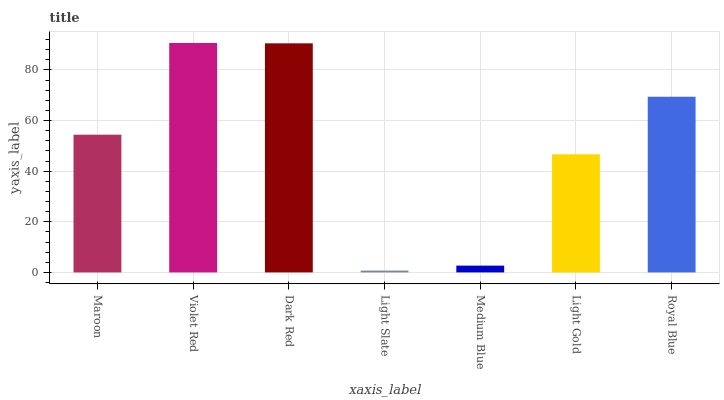Is Light Slate the minimum?
Answer yes or no. Yes. Is Violet Red the maximum?
Answer yes or no. Yes. Is Dark Red the minimum?
Answer yes or no. No. Is Dark Red the maximum?
Answer yes or no. No. Is Violet Red greater than Dark Red?
Answer yes or no. Yes. Is Dark Red less than Violet Red?
Answer yes or no. Yes. Is Dark Red greater than Violet Red?
Answer yes or no. No. Is Violet Red less than Dark Red?
Answer yes or no. No. Is Maroon the high median?
Answer yes or no. Yes. Is Maroon the low median?
Answer yes or no. Yes. Is Violet Red the high median?
Answer yes or no. No. Is Light Slate the low median?
Answer yes or no. No. 